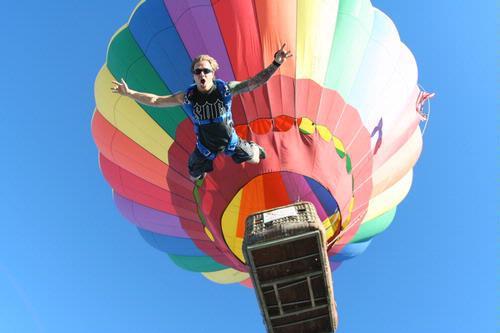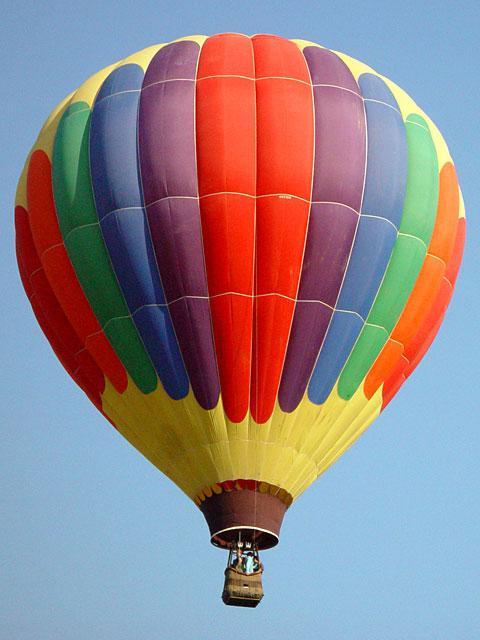The first image is the image on the left, the second image is the image on the right. Analyze the images presented: Is the assertion "A total of two hot air balloons with wicker baskets attached below are shown against the sky." valid? Answer yes or no. Yes. 